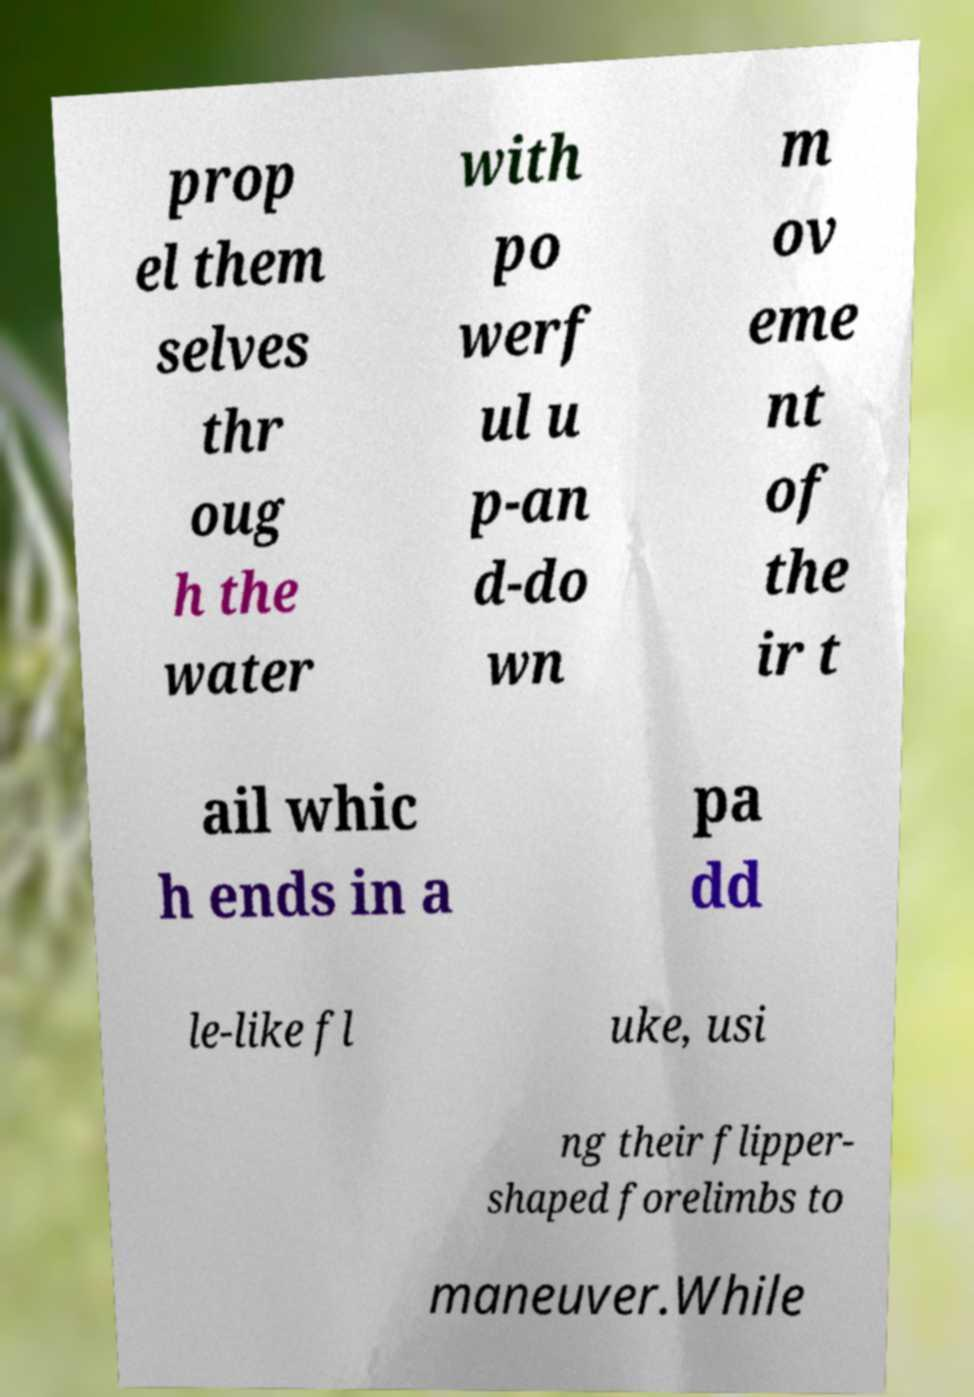Please read and relay the text visible in this image. What does it say? prop el them selves thr oug h the water with po werf ul u p-an d-do wn m ov eme nt of the ir t ail whic h ends in a pa dd le-like fl uke, usi ng their flipper- shaped forelimbs to maneuver.While 